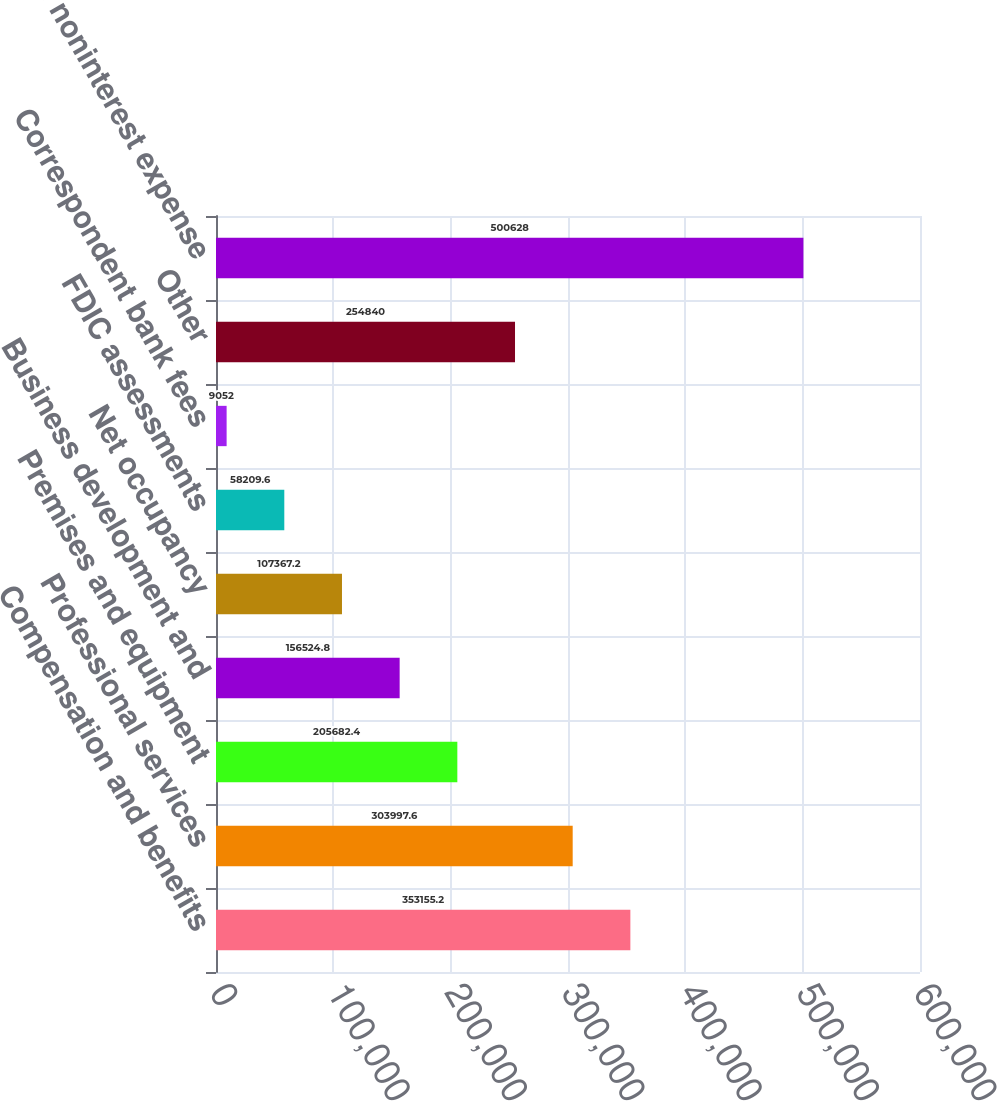<chart> <loc_0><loc_0><loc_500><loc_500><bar_chart><fcel>Compensation and benefits<fcel>Professional services<fcel>Premises and equipment<fcel>Business development and<fcel>Net occupancy<fcel>FDIC assessments<fcel>Correspondent bank fees<fcel>Other<fcel>Total noninterest expense<nl><fcel>353155<fcel>303998<fcel>205682<fcel>156525<fcel>107367<fcel>58209.6<fcel>9052<fcel>254840<fcel>500628<nl></chart> 